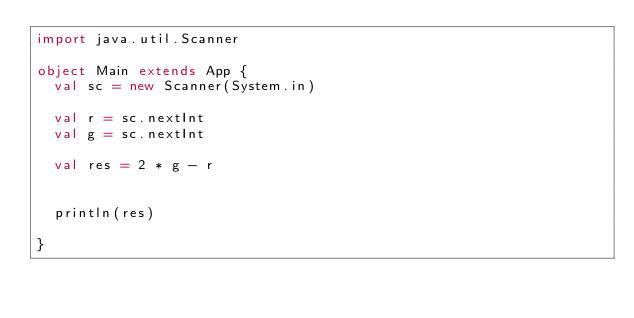Convert code to text. <code><loc_0><loc_0><loc_500><loc_500><_Scala_>import java.util.Scanner

object Main extends App {
  val sc = new Scanner(System.in)

  val r = sc.nextInt
  val g = sc.nextInt

  val res = 2 * g - r


  println(res)

}</code> 